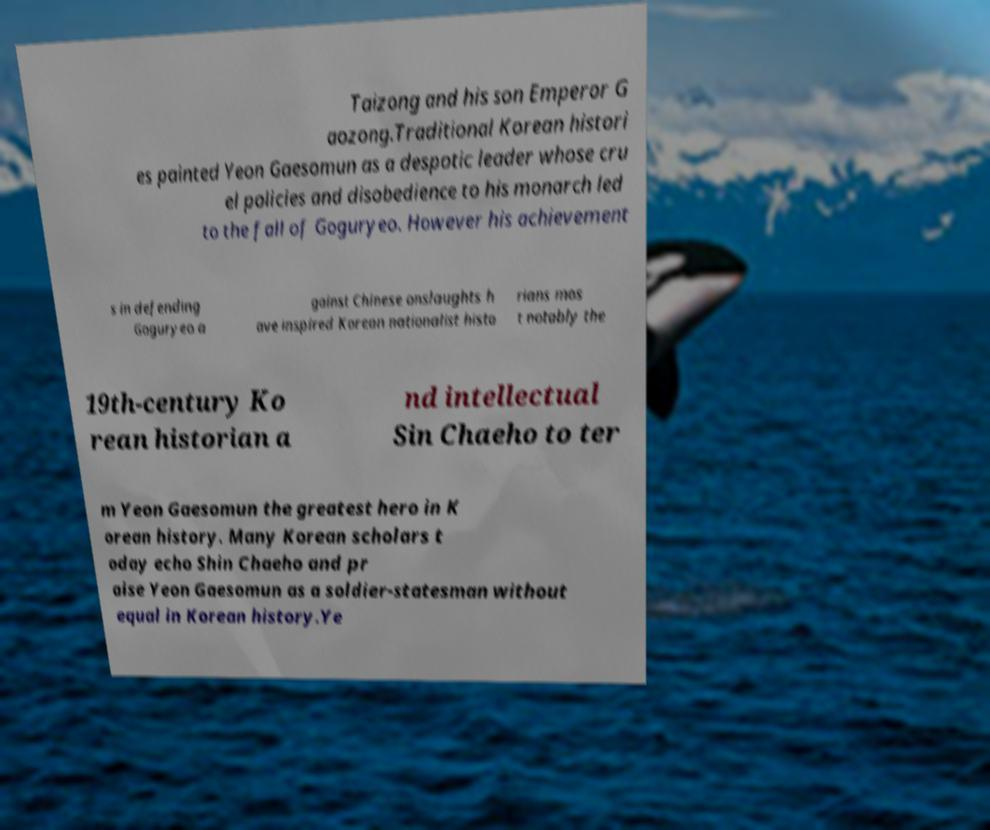Could you assist in decoding the text presented in this image and type it out clearly? Taizong and his son Emperor G aozong.Traditional Korean histori es painted Yeon Gaesomun as a despotic leader whose cru el policies and disobedience to his monarch led to the fall of Goguryeo. However his achievement s in defending Goguryeo a gainst Chinese onslaughts h ave inspired Korean nationalist histo rians mos t notably the 19th-century Ko rean historian a nd intellectual Sin Chaeho to ter m Yeon Gaesomun the greatest hero in K orean history. Many Korean scholars t oday echo Shin Chaeho and pr aise Yeon Gaesomun as a soldier-statesman without equal in Korean history.Ye 